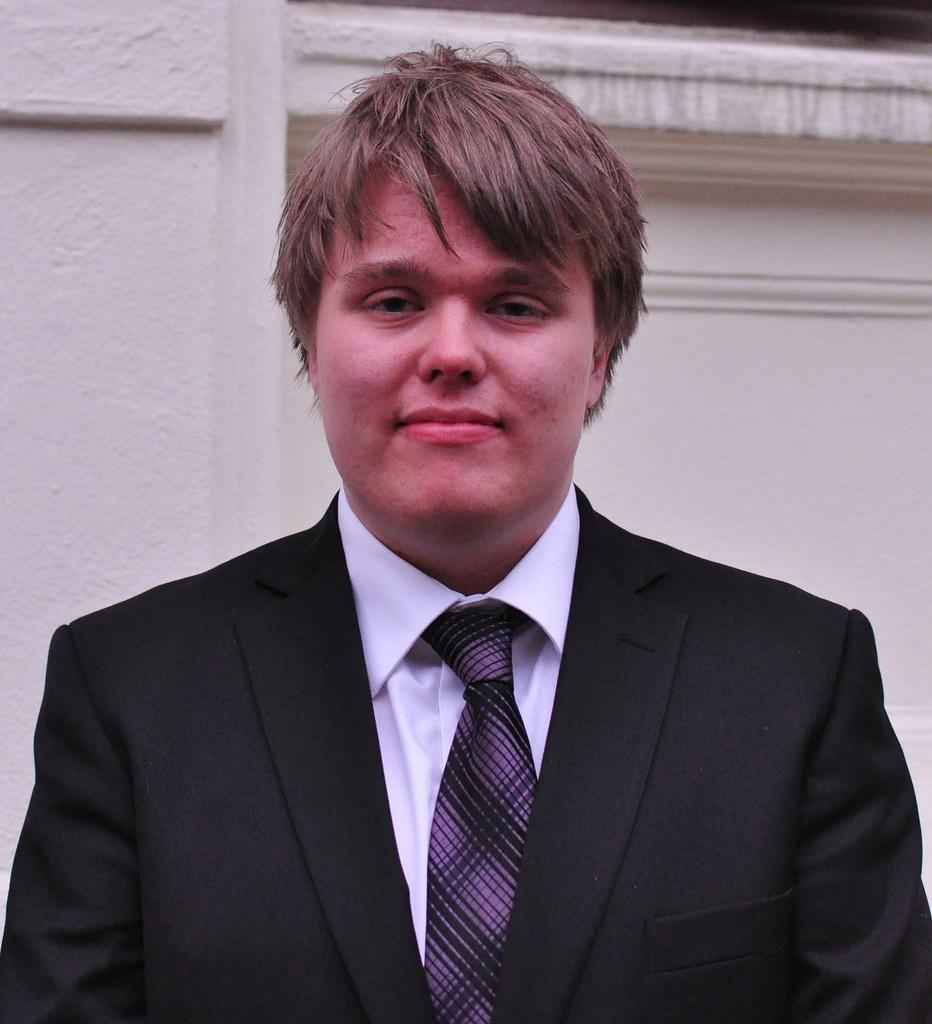What is the main subject of the image? There is a man standing in the center of the image. What is the man wearing? The man is wearing a suit. What can be seen in the background of the image? There is a wall in the background of the image. How many plates are stacked on the man's toes in the image? There are no plates or reference to toes in the image; the man is wearing a suit and standing in front of a wall. 